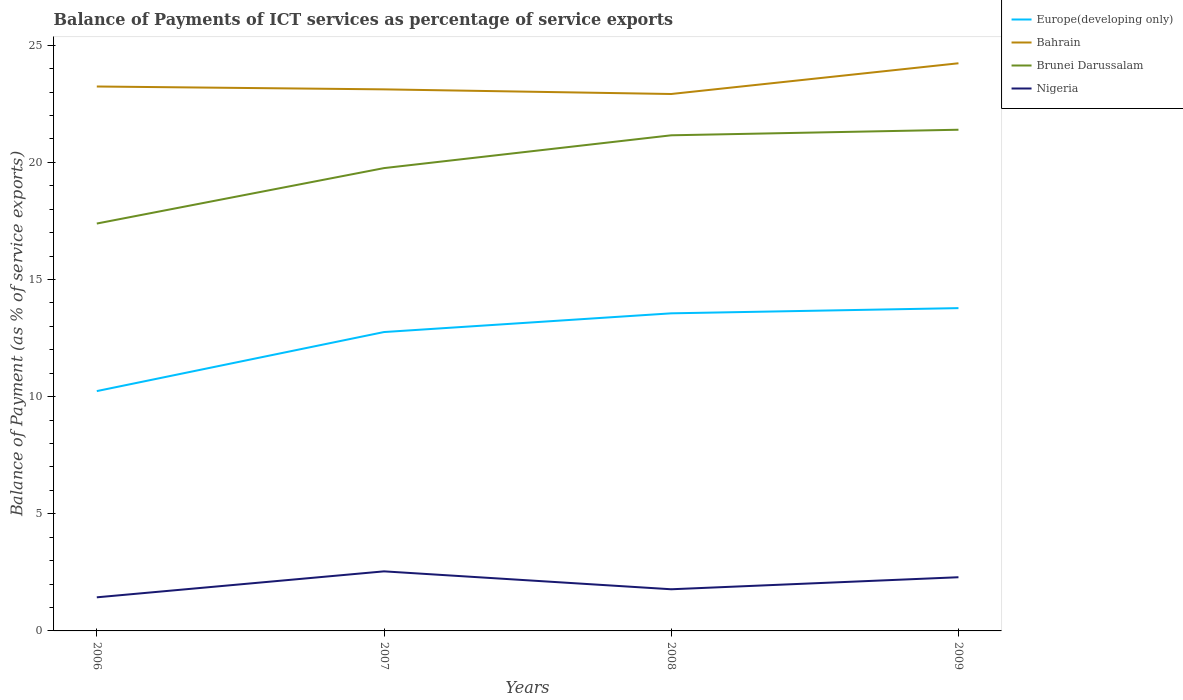How many different coloured lines are there?
Offer a terse response. 4. Does the line corresponding to Brunei Darussalam intersect with the line corresponding to Europe(developing only)?
Offer a very short reply. No. Across all years, what is the maximum balance of payments of ICT services in Bahrain?
Offer a terse response. 22.92. In which year was the balance of payments of ICT services in Brunei Darussalam maximum?
Your answer should be compact. 2006. What is the total balance of payments of ICT services in Europe(developing only) in the graph?
Give a very brief answer. -3.54. What is the difference between the highest and the second highest balance of payments of ICT services in Bahrain?
Your answer should be compact. 1.31. What is the difference between the highest and the lowest balance of payments of ICT services in Bahrain?
Give a very brief answer. 1. Is the balance of payments of ICT services in Europe(developing only) strictly greater than the balance of payments of ICT services in Brunei Darussalam over the years?
Give a very brief answer. Yes. How many lines are there?
Offer a very short reply. 4. How many years are there in the graph?
Ensure brevity in your answer.  4. What is the difference between two consecutive major ticks on the Y-axis?
Offer a terse response. 5. Are the values on the major ticks of Y-axis written in scientific E-notation?
Your response must be concise. No. Does the graph contain grids?
Give a very brief answer. No. How many legend labels are there?
Your answer should be very brief. 4. How are the legend labels stacked?
Make the answer very short. Vertical. What is the title of the graph?
Your response must be concise. Balance of Payments of ICT services as percentage of service exports. Does "Lao PDR" appear as one of the legend labels in the graph?
Make the answer very short. No. What is the label or title of the X-axis?
Make the answer very short. Years. What is the label or title of the Y-axis?
Provide a succinct answer. Balance of Payment (as % of service exports). What is the Balance of Payment (as % of service exports) of Europe(developing only) in 2006?
Keep it short and to the point. 10.24. What is the Balance of Payment (as % of service exports) in Bahrain in 2006?
Your response must be concise. 23.24. What is the Balance of Payment (as % of service exports) of Brunei Darussalam in 2006?
Offer a terse response. 17.39. What is the Balance of Payment (as % of service exports) in Nigeria in 2006?
Offer a very short reply. 1.43. What is the Balance of Payment (as % of service exports) in Europe(developing only) in 2007?
Your answer should be compact. 12.76. What is the Balance of Payment (as % of service exports) in Bahrain in 2007?
Your answer should be compact. 23.11. What is the Balance of Payment (as % of service exports) of Brunei Darussalam in 2007?
Provide a succinct answer. 19.75. What is the Balance of Payment (as % of service exports) in Nigeria in 2007?
Provide a succinct answer. 2.54. What is the Balance of Payment (as % of service exports) in Europe(developing only) in 2008?
Provide a succinct answer. 13.56. What is the Balance of Payment (as % of service exports) in Bahrain in 2008?
Your response must be concise. 22.92. What is the Balance of Payment (as % of service exports) in Brunei Darussalam in 2008?
Provide a succinct answer. 21.15. What is the Balance of Payment (as % of service exports) of Nigeria in 2008?
Offer a very short reply. 1.78. What is the Balance of Payment (as % of service exports) of Europe(developing only) in 2009?
Give a very brief answer. 13.78. What is the Balance of Payment (as % of service exports) of Bahrain in 2009?
Your answer should be very brief. 24.23. What is the Balance of Payment (as % of service exports) of Brunei Darussalam in 2009?
Your answer should be compact. 21.39. What is the Balance of Payment (as % of service exports) in Nigeria in 2009?
Make the answer very short. 2.29. Across all years, what is the maximum Balance of Payment (as % of service exports) in Europe(developing only)?
Provide a succinct answer. 13.78. Across all years, what is the maximum Balance of Payment (as % of service exports) in Bahrain?
Keep it short and to the point. 24.23. Across all years, what is the maximum Balance of Payment (as % of service exports) of Brunei Darussalam?
Provide a succinct answer. 21.39. Across all years, what is the maximum Balance of Payment (as % of service exports) in Nigeria?
Offer a terse response. 2.54. Across all years, what is the minimum Balance of Payment (as % of service exports) of Europe(developing only)?
Provide a succinct answer. 10.24. Across all years, what is the minimum Balance of Payment (as % of service exports) in Bahrain?
Make the answer very short. 22.92. Across all years, what is the minimum Balance of Payment (as % of service exports) in Brunei Darussalam?
Provide a succinct answer. 17.39. Across all years, what is the minimum Balance of Payment (as % of service exports) in Nigeria?
Keep it short and to the point. 1.43. What is the total Balance of Payment (as % of service exports) in Europe(developing only) in the graph?
Offer a terse response. 50.33. What is the total Balance of Payment (as % of service exports) of Bahrain in the graph?
Make the answer very short. 93.5. What is the total Balance of Payment (as % of service exports) of Brunei Darussalam in the graph?
Ensure brevity in your answer.  79.69. What is the total Balance of Payment (as % of service exports) of Nigeria in the graph?
Offer a terse response. 8.05. What is the difference between the Balance of Payment (as % of service exports) of Europe(developing only) in 2006 and that in 2007?
Your response must be concise. -2.52. What is the difference between the Balance of Payment (as % of service exports) of Bahrain in 2006 and that in 2007?
Provide a short and direct response. 0.12. What is the difference between the Balance of Payment (as % of service exports) of Brunei Darussalam in 2006 and that in 2007?
Your response must be concise. -2.37. What is the difference between the Balance of Payment (as % of service exports) of Nigeria in 2006 and that in 2007?
Give a very brief answer. -1.11. What is the difference between the Balance of Payment (as % of service exports) in Europe(developing only) in 2006 and that in 2008?
Provide a short and direct response. -3.32. What is the difference between the Balance of Payment (as % of service exports) of Bahrain in 2006 and that in 2008?
Offer a terse response. 0.32. What is the difference between the Balance of Payment (as % of service exports) of Brunei Darussalam in 2006 and that in 2008?
Provide a short and direct response. -3.77. What is the difference between the Balance of Payment (as % of service exports) of Nigeria in 2006 and that in 2008?
Provide a succinct answer. -0.34. What is the difference between the Balance of Payment (as % of service exports) of Europe(developing only) in 2006 and that in 2009?
Offer a very short reply. -3.54. What is the difference between the Balance of Payment (as % of service exports) in Bahrain in 2006 and that in 2009?
Ensure brevity in your answer.  -0.99. What is the difference between the Balance of Payment (as % of service exports) of Brunei Darussalam in 2006 and that in 2009?
Offer a terse response. -4. What is the difference between the Balance of Payment (as % of service exports) in Nigeria in 2006 and that in 2009?
Provide a short and direct response. -0.86. What is the difference between the Balance of Payment (as % of service exports) in Europe(developing only) in 2007 and that in 2008?
Provide a succinct answer. -0.8. What is the difference between the Balance of Payment (as % of service exports) in Bahrain in 2007 and that in 2008?
Ensure brevity in your answer.  0.2. What is the difference between the Balance of Payment (as % of service exports) in Brunei Darussalam in 2007 and that in 2008?
Your response must be concise. -1.4. What is the difference between the Balance of Payment (as % of service exports) of Nigeria in 2007 and that in 2008?
Make the answer very short. 0.76. What is the difference between the Balance of Payment (as % of service exports) of Europe(developing only) in 2007 and that in 2009?
Provide a short and direct response. -1.02. What is the difference between the Balance of Payment (as % of service exports) in Bahrain in 2007 and that in 2009?
Your answer should be very brief. -1.11. What is the difference between the Balance of Payment (as % of service exports) of Brunei Darussalam in 2007 and that in 2009?
Keep it short and to the point. -1.64. What is the difference between the Balance of Payment (as % of service exports) of Nigeria in 2007 and that in 2009?
Your response must be concise. 0.25. What is the difference between the Balance of Payment (as % of service exports) of Europe(developing only) in 2008 and that in 2009?
Offer a terse response. -0.22. What is the difference between the Balance of Payment (as % of service exports) in Bahrain in 2008 and that in 2009?
Your answer should be very brief. -1.31. What is the difference between the Balance of Payment (as % of service exports) in Brunei Darussalam in 2008 and that in 2009?
Ensure brevity in your answer.  -0.24. What is the difference between the Balance of Payment (as % of service exports) of Nigeria in 2008 and that in 2009?
Your response must be concise. -0.51. What is the difference between the Balance of Payment (as % of service exports) of Europe(developing only) in 2006 and the Balance of Payment (as % of service exports) of Bahrain in 2007?
Ensure brevity in your answer.  -12.88. What is the difference between the Balance of Payment (as % of service exports) in Europe(developing only) in 2006 and the Balance of Payment (as % of service exports) in Brunei Darussalam in 2007?
Your response must be concise. -9.52. What is the difference between the Balance of Payment (as % of service exports) of Europe(developing only) in 2006 and the Balance of Payment (as % of service exports) of Nigeria in 2007?
Your response must be concise. 7.69. What is the difference between the Balance of Payment (as % of service exports) of Bahrain in 2006 and the Balance of Payment (as % of service exports) of Brunei Darussalam in 2007?
Offer a very short reply. 3.48. What is the difference between the Balance of Payment (as % of service exports) of Bahrain in 2006 and the Balance of Payment (as % of service exports) of Nigeria in 2007?
Offer a very short reply. 20.69. What is the difference between the Balance of Payment (as % of service exports) of Brunei Darussalam in 2006 and the Balance of Payment (as % of service exports) of Nigeria in 2007?
Your answer should be very brief. 14.84. What is the difference between the Balance of Payment (as % of service exports) of Europe(developing only) in 2006 and the Balance of Payment (as % of service exports) of Bahrain in 2008?
Provide a succinct answer. -12.68. What is the difference between the Balance of Payment (as % of service exports) in Europe(developing only) in 2006 and the Balance of Payment (as % of service exports) in Brunei Darussalam in 2008?
Offer a terse response. -10.92. What is the difference between the Balance of Payment (as % of service exports) in Europe(developing only) in 2006 and the Balance of Payment (as % of service exports) in Nigeria in 2008?
Offer a very short reply. 8.46. What is the difference between the Balance of Payment (as % of service exports) in Bahrain in 2006 and the Balance of Payment (as % of service exports) in Brunei Darussalam in 2008?
Ensure brevity in your answer.  2.08. What is the difference between the Balance of Payment (as % of service exports) in Bahrain in 2006 and the Balance of Payment (as % of service exports) in Nigeria in 2008?
Keep it short and to the point. 21.46. What is the difference between the Balance of Payment (as % of service exports) of Brunei Darussalam in 2006 and the Balance of Payment (as % of service exports) of Nigeria in 2008?
Keep it short and to the point. 15.61. What is the difference between the Balance of Payment (as % of service exports) of Europe(developing only) in 2006 and the Balance of Payment (as % of service exports) of Bahrain in 2009?
Make the answer very short. -13.99. What is the difference between the Balance of Payment (as % of service exports) in Europe(developing only) in 2006 and the Balance of Payment (as % of service exports) in Brunei Darussalam in 2009?
Your response must be concise. -11.16. What is the difference between the Balance of Payment (as % of service exports) of Europe(developing only) in 2006 and the Balance of Payment (as % of service exports) of Nigeria in 2009?
Provide a short and direct response. 7.94. What is the difference between the Balance of Payment (as % of service exports) in Bahrain in 2006 and the Balance of Payment (as % of service exports) in Brunei Darussalam in 2009?
Offer a terse response. 1.85. What is the difference between the Balance of Payment (as % of service exports) of Bahrain in 2006 and the Balance of Payment (as % of service exports) of Nigeria in 2009?
Your answer should be very brief. 20.95. What is the difference between the Balance of Payment (as % of service exports) in Brunei Darussalam in 2006 and the Balance of Payment (as % of service exports) in Nigeria in 2009?
Your response must be concise. 15.1. What is the difference between the Balance of Payment (as % of service exports) in Europe(developing only) in 2007 and the Balance of Payment (as % of service exports) in Bahrain in 2008?
Ensure brevity in your answer.  -10.16. What is the difference between the Balance of Payment (as % of service exports) of Europe(developing only) in 2007 and the Balance of Payment (as % of service exports) of Brunei Darussalam in 2008?
Ensure brevity in your answer.  -8.4. What is the difference between the Balance of Payment (as % of service exports) of Europe(developing only) in 2007 and the Balance of Payment (as % of service exports) of Nigeria in 2008?
Ensure brevity in your answer.  10.98. What is the difference between the Balance of Payment (as % of service exports) in Bahrain in 2007 and the Balance of Payment (as % of service exports) in Brunei Darussalam in 2008?
Your answer should be very brief. 1.96. What is the difference between the Balance of Payment (as % of service exports) in Bahrain in 2007 and the Balance of Payment (as % of service exports) in Nigeria in 2008?
Offer a terse response. 21.34. What is the difference between the Balance of Payment (as % of service exports) in Brunei Darussalam in 2007 and the Balance of Payment (as % of service exports) in Nigeria in 2008?
Provide a succinct answer. 17.98. What is the difference between the Balance of Payment (as % of service exports) of Europe(developing only) in 2007 and the Balance of Payment (as % of service exports) of Bahrain in 2009?
Your response must be concise. -11.47. What is the difference between the Balance of Payment (as % of service exports) in Europe(developing only) in 2007 and the Balance of Payment (as % of service exports) in Brunei Darussalam in 2009?
Give a very brief answer. -8.63. What is the difference between the Balance of Payment (as % of service exports) in Europe(developing only) in 2007 and the Balance of Payment (as % of service exports) in Nigeria in 2009?
Keep it short and to the point. 10.47. What is the difference between the Balance of Payment (as % of service exports) in Bahrain in 2007 and the Balance of Payment (as % of service exports) in Brunei Darussalam in 2009?
Keep it short and to the point. 1.72. What is the difference between the Balance of Payment (as % of service exports) in Bahrain in 2007 and the Balance of Payment (as % of service exports) in Nigeria in 2009?
Keep it short and to the point. 20.82. What is the difference between the Balance of Payment (as % of service exports) in Brunei Darussalam in 2007 and the Balance of Payment (as % of service exports) in Nigeria in 2009?
Give a very brief answer. 17.46. What is the difference between the Balance of Payment (as % of service exports) in Europe(developing only) in 2008 and the Balance of Payment (as % of service exports) in Bahrain in 2009?
Make the answer very short. -10.67. What is the difference between the Balance of Payment (as % of service exports) in Europe(developing only) in 2008 and the Balance of Payment (as % of service exports) in Brunei Darussalam in 2009?
Keep it short and to the point. -7.84. What is the difference between the Balance of Payment (as % of service exports) in Europe(developing only) in 2008 and the Balance of Payment (as % of service exports) in Nigeria in 2009?
Your answer should be compact. 11.26. What is the difference between the Balance of Payment (as % of service exports) in Bahrain in 2008 and the Balance of Payment (as % of service exports) in Brunei Darussalam in 2009?
Offer a terse response. 1.53. What is the difference between the Balance of Payment (as % of service exports) in Bahrain in 2008 and the Balance of Payment (as % of service exports) in Nigeria in 2009?
Your response must be concise. 20.63. What is the difference between the Balance of Payment (as % of service exports) of Brunei Darussalam in 2008 and the Balance of Payment (as % of service exports) of Nigeria in 2009?
Provide a succinct answer. 18.86. What is the average Balance of Payment (as % of service exports) of Europe(developing only) per year?
Provide a succinct answer. 12.58. What is the average Balance of Payment (as % of service exports) in Bahrain per year?
Keep it short and to the point. 23.37. What is the average Balance of Payment (as % of service exports) of Brunei Darussalam per year?
Provide a short and direct response. 19.92. What is the average Balance of Payment (as % of service exports) of Nigeria per year?
Offer a terse response. 2.01. In the year 2006, what is the difference between the Balance of Payment (as % of service exports) of Europe(developing only) and Balance of Payment (as % of service exports) of Bahrain?
Provide a short and direct response. -13. In the year 2006, what is the difference between the Balance of Payment (as % of service exports) of Europe(developing only) and Balance of Payment (as % of service exports) of Brunei Darussalam?
Ensure brevity in your answer.  -7.15. In the year 2006, what is the difference between the Balance of Payment (as % of service exports) of Europe(developing only) and Balance of Payment (as % of service exports) of Nigeria?
Your answer should be compact. 8.8. In the year 2006, what is the difference between the Balance of Payment (as % of service exports) in Bahrain and Balance of Payment (as % of service exports) in Brunei Darussalam?
Your answer should be very brief. 5.85. In the year 2006, what is the difference between the Balance of Payment (as % of service exports) in Bahrain and Balance of Payment (as % of service exports) in Nigeria?
Give a very brief answer. 21.8. In the year 2006, what is the difference between the Balance of Payment (as % of service exports) of Brunei Darussalam and Balance of Payment (as % of service exports) of Nigeria?
Offer a terse response. 15.95. In the year 2007, what is the difference between the Balance of Payment (as % of service exports) in Europe(developing only) and Balance of Payment (as % of service exports) in Bahrain?
Ensure brevity in your answer.  -10.36. In the year 2007, what is the difference between the Balance of Payment (as % of service exports) in Europe(developing only) and Balance of Payment (as % of service exports) in Brunei Darussalam?
Ensure brevity in your answer.  -7. In the year 2007, what is the difference between the Balance of Payment (as % of service exports) of Europe(developing only) and Balance of Payment (as % of service exports) of Nigeria?
Keep it short and to the point. 10.21. In the year 2007, what is the difference between the Balance of Payment (as % of service exports) in Bahrain and Balance of Payment (as % of service exports) in Brunei Darussalam?
Your answer should be very brief. 3.36. In the year 2007, what is the difference between the Balance of Payment (as % of service exports) of Bahrain and Balance of Payment (as % of service exports) of Nigeria?
Keep it short and to the point. 20.57. In the year 2007, what is the difference between the Balance of Payment (as % of service exports) of Brunei Darussalam and Balance of Payment (as % of service exports) of Nigeria?
Your response must be concise. 17.21. In the year 2008, what is the difference between the Balance of Payment (as % of service exports) of Europe(developing only) and Balance of Payment (as % of service exports) of Bahrain?
Your answer should be compact. -9.36. In the year 2008, what is the difference between the Balance of Payment (as % of service exports) of Europe(developing only) and Balance of Payment (as % of service exports) of Brunei Darussalam?
Provide a succinct answer. -7.6. In the year 2008, what is the difference between the Balance of Payment (as % of service exports) of Europe(developing only) and Balance of Payment (as % of service exports) of Nigeria?
Keep it short and to the point. 11.78. In the year 2008, what is the difference between the Balance of Payment (as % of service exports) of Bahrain and Balance of Payment (as % of service exports) of Brunei Darussalam?
Ensure brevity in your answer.  1.76. In the year 2008, what is the difference between the Balance of Payment (as % of service exports) of Bahrain and Balance of Payment (as % of service exports) of Nigeria?
Offer a very short reply. 21.14. In the year 2008, what is the difference between the Balance of Payment (as % of service exports) of Brunei Darussalam and Balance of Payment (as % of service exports) of Nigeria?
Give a very brief answer. 19.38. In the year 2009, what is the difference between the Balance of Payment (as % of service exports) in Europe(developing only) and Balance of Payment (as % of service exports) in Bahrain?
Offer a terse response. -10.45. In the year 2009, what is the difference between the Balance of Payment (as % of service exports) of Europe(developing only) and Balance of Payment (as % of service exports) of Brunei Darussalam?
Your answer should be compact. -7.61. In the year 2009, what is the difference between the Balance of Payment (as % of service exports) in Europe(developing only) and Balance of Payment (as % of service exports) in Nigeria?
Your answer should be very brief. 11.49. In the year 2009, what is the difference between the Balance of Payment (as % of service exports) in Bahrain and Balance of Payment (as % of service exports) in Brunei Darussalam?
Your response must be concise. 2.84. In the year 2009, what is the difference between the Balance of Payment (as % of service exports) of Bahrain and Balance of Payment (as % of service exports) of Nigeria?
Your response must be concise. 21.94. In the year 2009, what is the difference between the Balance of Payment (as % of service exports) of Brunei Darussalam and Balance of Payment (as % of service exports) of Nigeria?
Your answer should be very brief. 19.1. What is the ratio of the Balance of Payment (as % of service exports) of Europe(developing only) in 2006 to that in 2007?
Offer a very short reply. 0.8. What is the ratio of the Balance of Payment (as % of service exports) of Bahrain in 2006 to that in 2007?
Your answer should be very brief. 1.01. What is the ratio of the Balance of Payment (as % of service exports) in Brunei Darussalam in 2006 to that in 2007?
Provide a succinct answer. 0.88. What is the ratio of the Balance of Payment (as % of service exports) of Nigeria in 2006 to that in 2007?
Make the answer very short. 0.56. What is the ratio of the Balance of Payment (as % of service exports) in Europe(developing only) in 2006 to that in 2008?
Ensure brevity in your answer.  0.76. What is the ratio of the Balance of Payment (as % of service exports) of Bahrain in 2006 to that in 2008?
Keep it short and to the point. 1.01. What is the ratio of the Balance of Payment (as % of service exports) in Brunei Darussalam in 2006 to that in 2008?
Your response must be concise. 0.82. What is the ratio of the Balance of Payment (as % of service exports) in Nigeria in 2006 to that in 2008?
Make the answer very short. 0.81. What is the ratio of the Balance of Payment (as % of service exports) of Europe(developing only) in 2006 to that in 2009?
Offer a terse response. 0.74. What is the ratio of the Balance of Payment (as % of service exports) of Bahrain in 2006 to that in 2009?
Make the answer very short. 0.96. What is the ratio of the Balance of Payment (as % of service exports) in Brunei Darussalam in 2006 to that in 2009?
Provide a short and direct response. 0.81. What is the ratio of the Balance of Payment (as % of service exports) in Nigeria in 2006 to that in 2009?
Provide a succinct answer. 0.63. What is the ratio of the Balance of Payment (as % of service exports) of Europe(developing only) in 2007 to that in 2008?
Your answer should be very brief. 0.94. What is the ratio of the Balance of Payment (as % of service exports) of Bahrain in 2007 to that in 2008?
Your response must be concise. 1.01. What is the ratio of the Balance of Payment (as % of service exports) in Brunei Darussalam in 2007 to that in 2008?
Your answer should be very brief. 0.93. What is the ratio of the Balance of Payment (as % of service exports) in Nigeria in 2007 to that in 2008?
Your response must be concise. 1.43. What is the ratio of the Balance of Payment (as % of service exports) in Europe(developing only) in 2007 to that in 2009?
Offer a very short reply. 0.93. What is the ratio of the Balance of Payment (as % of service exports) of Bahrain in 2007 to that in 2009?
Your answer should be very brief. 0.95. What is the ratio of the Balance of Payment (as % of service exports) of Brunei Darussalam in 2007 to that in 2009?
Keep it short and to the point. 0.92. What is the ratio of the Balance of Payment (as % of service exports) in Nigeria in 2007 to that in 2009?
Keep it short and to the point. 1.11. What is the ratio of the Balance of Payment (as % of service exports) of Europe(developing only) in 2008 to that in 2009?
Provide a succinct answer. 0.98. What is the ratio of the Balance of Payment (as % of service exports) of Bahrain in 2008 to that in 2009?
Offer a very short reply. 0.95. What is the ratio of the Balance of Payment (as % of service exports) in Brunei Darussalam in 2008 to that in 2009?
Make the answer very short. 0.99. What is the ratio of the Balance of Payment (as % of service exports) in Nigeria in 2008 to that in 2009?
Make the answer very short. 0.78. What is the difference between the highest and the second highest Balance of Payment (as % of service exports) in Europe(developing only)?
Keep it short and to the point. 0.22. What is the difference between the highest and the second highest Balance of Payment (as % of service exports) of Bahrain?
Ensure brevity in your answer.  0.99. What is the difference between the highest and the second highest Balance of Payment (as % of service exports) in Brunei Darussalam?
Offer a very short reply. 0.24. What is the difference between the highest and the second highest Balance of Payment (as % of service exports) of Nigeria?
Give a very brief answer. 0.25. What is the difference between the highest and the lowest Balance of Payment (as % of service exports) in Europe(developing only)?
Provide a short and direct response. 3.54. What is the difference between the highest and the lowest Balance of Payment (as % of service exports) in Bahrain?
Your response must be concise. 1.31. What is the difference between the highest and the lowest Balance of Payment (as % of service exports) of Brunei Darussalam?
Offer a very short reply. 4. What is the difference between the highest and the lowest Balance of Payment (as % of service exports) in Nigeria?
Your answer should be very brief. 1.11. 